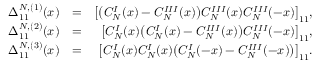Convert formula to latex. <formula><loc_0><loc_0><loc_500><loc_500>\begin{array} { r l r } { \Delta _ { 1 1 } ^ { N , ( 1 ) } ( x ) } & { = } & { \left [ \left ( C _ { N } ^ { I } ( x ) - C _ { N } ^ { I I I } ( x ) \right ) C _ { N } ^ { I I I } ( x ) C _ { N } ^ { I I I } ( - x ) \right ] _ { 1 1 } , } \\ { \Delta _ { 1 1 } ^ { N , ( 2 ) } ( x ) } & { = } & { \left [ C _ { N } ^ { I } ( x ) \left ( C _ { N } ^ { I } ( x ) - C _ { N } ^ { I I I } ( x ) \right ) C _ { N } ^ { I I I } ( - x ) \right ] _ { 1 1 } , } \\ { \Delta _ { 1 1 } ^ { N , ( 3 ) } ( x ) } & { = } & { \left [ C _ { N } ^ { I } ( x ) C _ { N } ^ { I } ( x ) \left ( C _ { N } ^ { I } ( - x ) - C _ { N } ^ { I I I } ( - x ) \right ) \right ] _ { 1 1 } . } \end{array}</formula> 